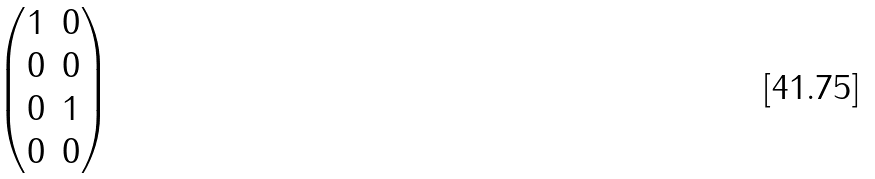<formula> <loc_0><loc_0><loc_500><loc_500>\begin{pmatrix} 1 & 0 \\ 0 & 0 \\ 0 & 1 \\ 0 & 0 \end{pmatrix}</formula> 